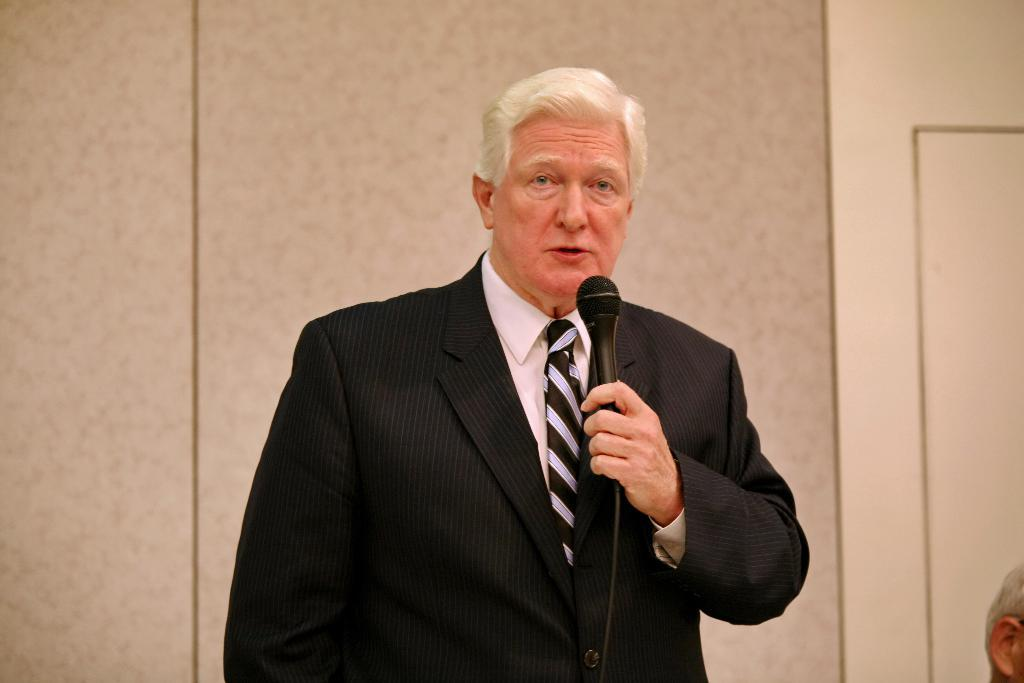Who is the main subject in the image? There is a man in the image. What is the man wearing? The man is wearing a black blazer. What object is the man holding in his hand? The man is holding a microphone in his hand. What is the man doing in the image? The man is speaking. What type of animal can be seen in the background of the image? There is no animal visible in the image; it features a man wearing a black blazer, holding a microphone, and speaking. 